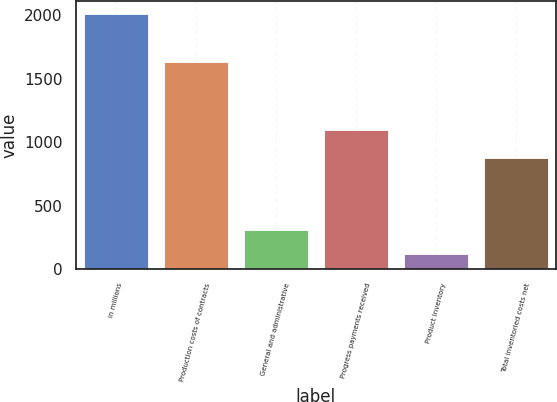Convert chart to OTSL. <chart><loc_0><loc_0><loc_500><loc_500><bar_chart><fcel>in millions<fcel>Production costs of contracts<fcel>General and administrative<fcel>Progress payments received<fcel>Product inventory<fcel>Total inventoried costs net<nl><fcel>2011<fcel>1629<fcel>311.8<fcel>1100<fcel>123<fcel>873<nl></chart> 